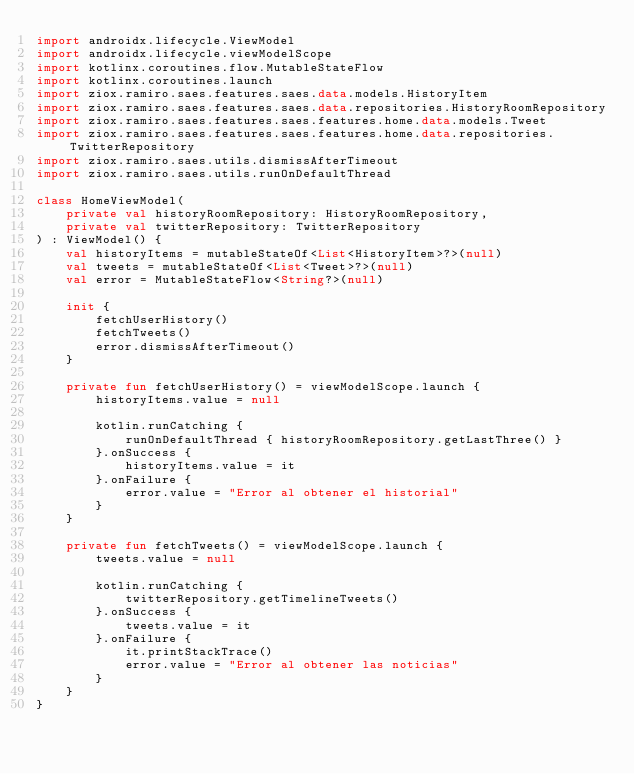<code> <loc_0><loc_0><loc_500><loc_500><_Kotlin_>import androidx.lifecycle.ViewModel
import androidx.lifecycle.viewModelScope
import kotlinx.coroutines.flow.MutableStateFlow
import kotlinx.coroutines.launch
import ziox.ramiro.saes.features.saes.data.models.HistoryItem
import ziox.ramiro.saes.features.saes.data.repositories.HistoryRoomRepository
import ziox.ramiro.saes.features.saes.features.home.data.models.Tweet
import ziox.ramiro.saes.features.saes.features.home.data.repositories.TwitterRepository
import ziox.ramiro.saes.utils.dismissAfterTimeout
import ziox.ramiro.saes.utils.runOnDefaultThread

class HomeViewModel(
    private val historyRoomRepository: HistoryRoomRepository,
    private val twitterRepository: TwitterRepository
) : ViewModel() {
    val historyItems = mutableStateOf<List<HistoryItem>?>(null)
    val tweets = mutableStateOf<List<Tweet>?>(null)
    val error = MutableStateFlow<String?>(null)

    init {
        fetchUserHistory()
        fetchTweets()
        error.dismissAfterTimeout()
    }

    private fun fetchUserHistory() = viewModelScope.launch {
        historyItems.value = null

        kotlin.runCatching {
            runOnDefaultThread { historyRoomRepository.getLastThree() }
        }.onSuccess {
            historyItems.value = it
        }.onFailure {
            error.value = "Error al obtener el historial"
        }
    }

    private fun fetchTweets() = viewModelScope.launch {
        tweets.value = null

        kotlin.runCatching {
            twitterRepository.getTimelineTweets()
        }.onSuccess {
            tweets.value = it
        }.onFailure {
            it.printStackTrace()
            error.value = "Error al obtener las noticias"
        }
    }
}</code> 